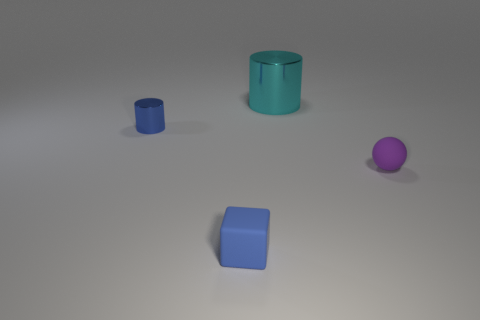Add 2 red cubes. How many objects exist? 6 Subtract all blocks. How many objects are left? 3 Add 3 tiny blue things. How many tiny blue things are left? 5 Add 4 small balls. How many small balls exist? 5 Subtract 1 cyan cylinders. How many objects are left? 3 Subtract all big things. Subtract all small things. How many objects are left? 0 